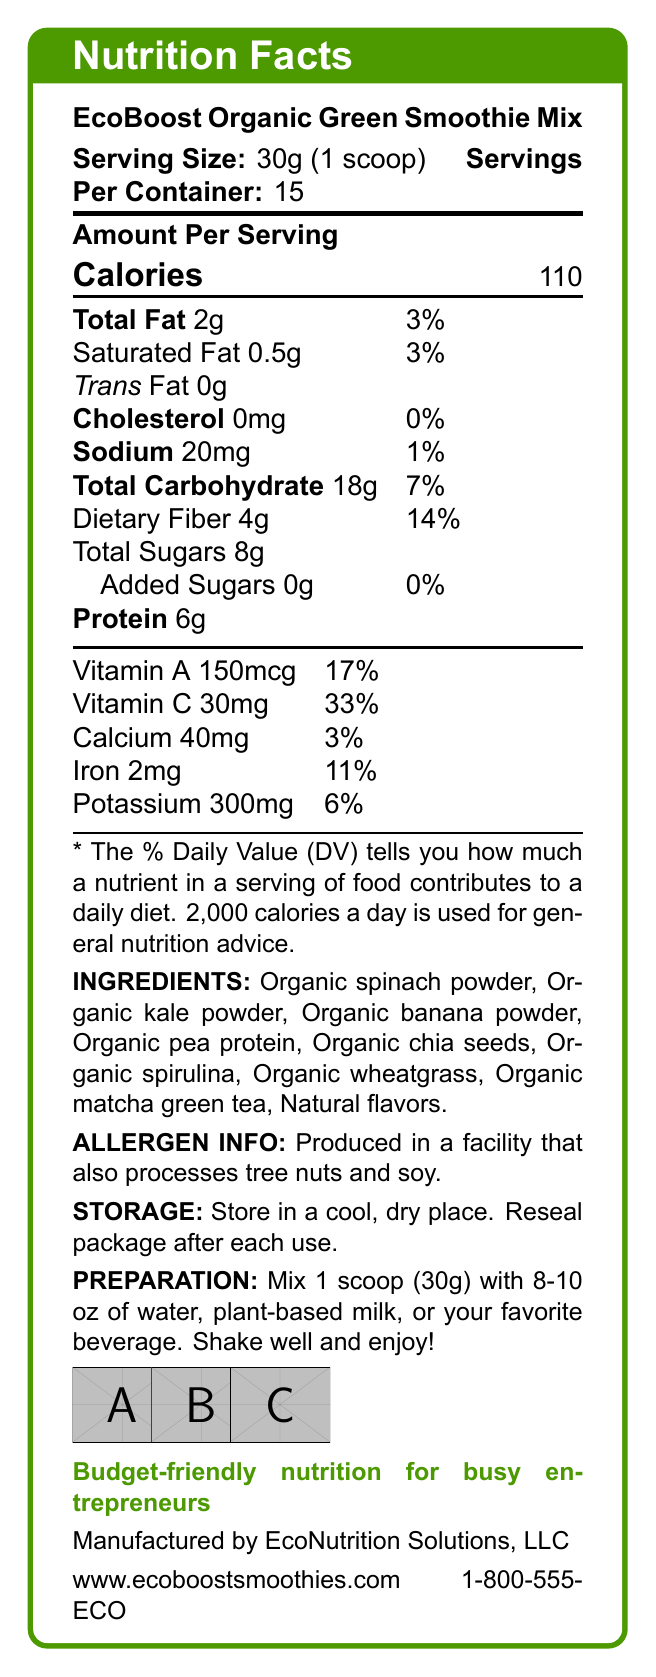what is the serving size for EcoBoost Organic Green Smoothie Mix? The serving size is listed at the start of the nutrition facts, indicating 30g or 1 scoop.
Answer: 30g (1 scoop) how many servings are in one container? The document specifies that there are 15 servings per container.
Answer: 15 servings how many calories are in one serving of the smoothie mix? The number of calories per serving is indicated as 110 in the nutrition facts section.
Answer: 110 calories how much total fat does one serving contain? The total fat content per serving is provided in the nutrition facts and is 2 grams.
Answer: 2g what is the percentage of daily value for vitamin C in one serving? The document states that one serving contains 33% of the daily value for vitamin C.
Answer: 33% what is the daily value percentage of dietary fiber in one serving? According to the nutrition facts, dietary fiber in one serving is 14% of the daily value.
Answer: 14% which of the following is an ingredient in the smoothie mix? A. Organic spinach powder B. Natural sweeteners C. Artificial flavors D. Soy protein The ingredient list includes Organic spinach powder, while natural sweeteners, artificial flavors, and soy protein are not mentioned.
Answer: A. Organic spinach powder what certifications does EcoBoost Organic Green Smoothie Mix have? A. USDA Organic B. Gluten-Free C. Non-GMO Project Verified D. Vegan The document lists certifications including USDA Organic, Non-GMO Project Verified, and Vegan.
Answer: A. USDA Organic, C. Non-GMO Project Verified, D. Vegan is there any cholesterol in one serving of this smoothie mix? The document clearly states that there is 0mg of cholesterol per serving.
Answer: No summarize the main idea of the document. The summary describes the essential aspects of the document, highlighting the product details, nutrition information, and additional relevant data for EcoBoost Organic Green Smoothie Mix.
Answer: The document provides the nutrition facts and other relevant details about EcoBoost Organic Green Smoothie Mix, a budget-friendly, organic product designed for health-conscious small business owners. It includes information on serving size, caloric content, nutrient values, ingredients, allergen info, storage and preparation instructions, certifications, marketing claims, sustainability, brand values, and contact information. how many grams of added sugars are in one serving? The nutrition facts show that there are 0g of added sugars in one serving.
Answer: 0g what natural ingredient is used for flavoring in the smoothie mix? The ingredient list at the bottom of the nutrition facts includes "Natural flavors".
Answer: Natural flavors what is the sodium content per serving? The sodium content is listed as 20mg per serving in the nutrition facts.
Answer: 20mg which company manufactures the EcoBoost Organic Green Smoothie Mix? The document states that the product is manufactured by EcoNutrition Solutions, LLC.
Answer: EcoNutrition Solutions, LLC how many grams of protein are in each serving? The document shows that each serving contains 6 grams of protein.
Answer: 6g is this product safe for someone with a tree nut allergy? The allergen info mentions that the product is produced in a facility that also processes tree nuts, which might pose a risk, but it doesn’t clarify if there are any tree nuts in the product itself.
Answer: Cannot be determined 